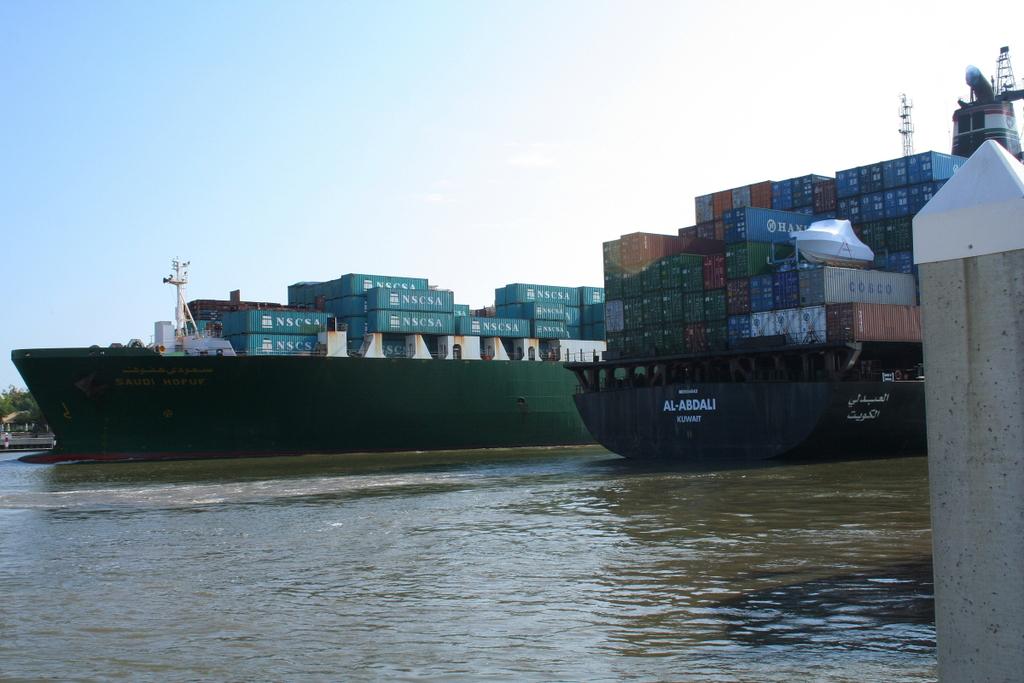Is the black boat going to kuwait?
Keep it short and to the point. Unanswerable. 